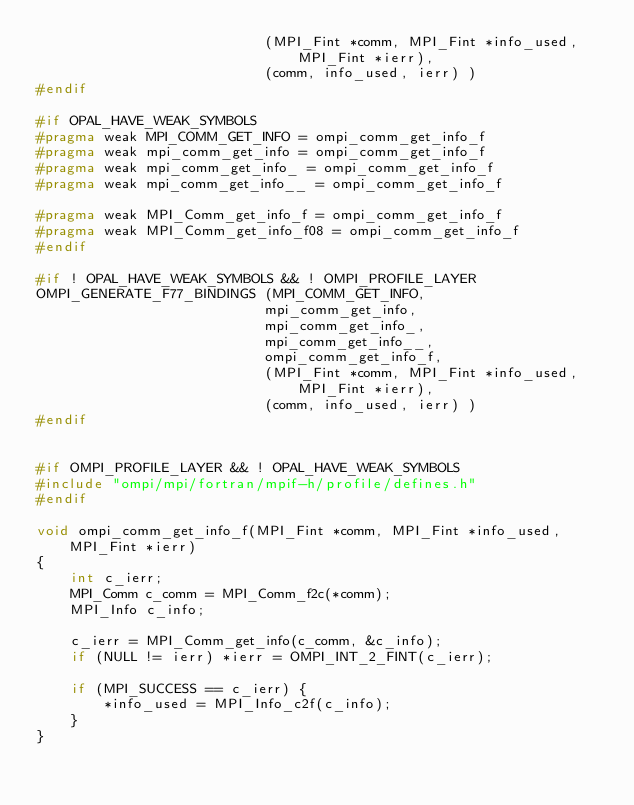<code> <loc_0><loc_0><loc_500><loc_500><_C_>                           (MPI_Fint *comm, MPI_Fint *info_used, MPI_Fint *ierr),
                           (comm, info_used, ierr) )
#endif

#if OPAL_HAVE_WEAK_SYMBOLS
#pragma weak MPI_COMM_GET_INFO = ompi_comm_get_info_f
#pragma weak mpi_comm_get_info = ompi_comm_get_info_f
#pragma weak mpi_comm_get_info_ = ompi_comm_get_info_f
#pragma weak mpi_comm_get_info__ = ompi_comm_get_info_f

#pragma weak MPI_Comm_get_info_f = ompi_comm_get_info_f
#pragma weak MPI_Comm_get_info_f08 = ompi_comm_get_info_f
#endif

#if ! OPAL_HAVE_WEAK_SYMBOLS && ! OMPI_PROFILE_LAYER
OMPI_GENERATE_F77_BINDINGS (MPI_COMM_GET_INFO,
                           mpi_comm_get_info,
                           mpi_comm_get_info_,
                           mpi_comm_get_info__,
                           ompi_comm_get_info_f,
                           (MPI_Fint *comm, MPI_Fint *info_used, MPI_Fint *ierr),
                           (comm, info_used, ierr) )
#endif


#if OMPI_PROFILE_LAYER && ! OPAL_HAVE_WEAK_SYMBOLS
#include "ompi/mpi/fortran/mpif-h/profile/defines.h"
#endif

void ompi_comm_get_info_f(MPI_Fint *comm, MPI_Fint *info_used, MPI_Fint *ierr)
{
    int c_ierr;
    MPI_Comm c_comm = MPI_Comm_f2c(*comm);
    MPI_Info c_info;

    c_ierr = MPI_Comm_get_info(c_comm, &c_info);
    if (NULL != ierr) *ierr = OMPI_INT_2_FINT(c_ierr);

    if (MPI_SUCCESS == c_ierr) {
        *info_used = MPI_Info_c2f(c_info);
    }
}
</code> 